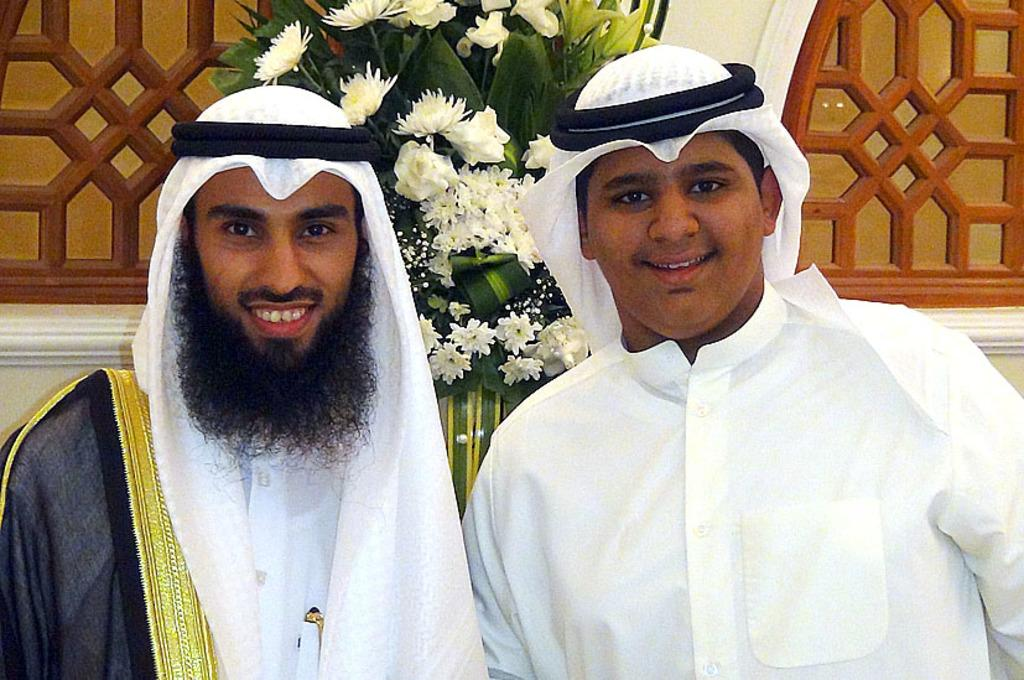How many people are present in the image? There are two people in the image. What are the people wearing on their heads? Both people are wearing headscarves. What can be seen in the background of the image? There is a flower bouquet, a wall, and windows in the background of the image. What type of beef is being prepared on the farm in the image? There is no farm or beef present in the image; it features two people wearing headscarves and a background with a flower bouquet, a wall, and windows. How many cats can be seen playing with the flower bouquet in the image? There are no cats present in the image; it only features two people wearing headscarves and a background with a flower bouquet, a wall, and windows. 